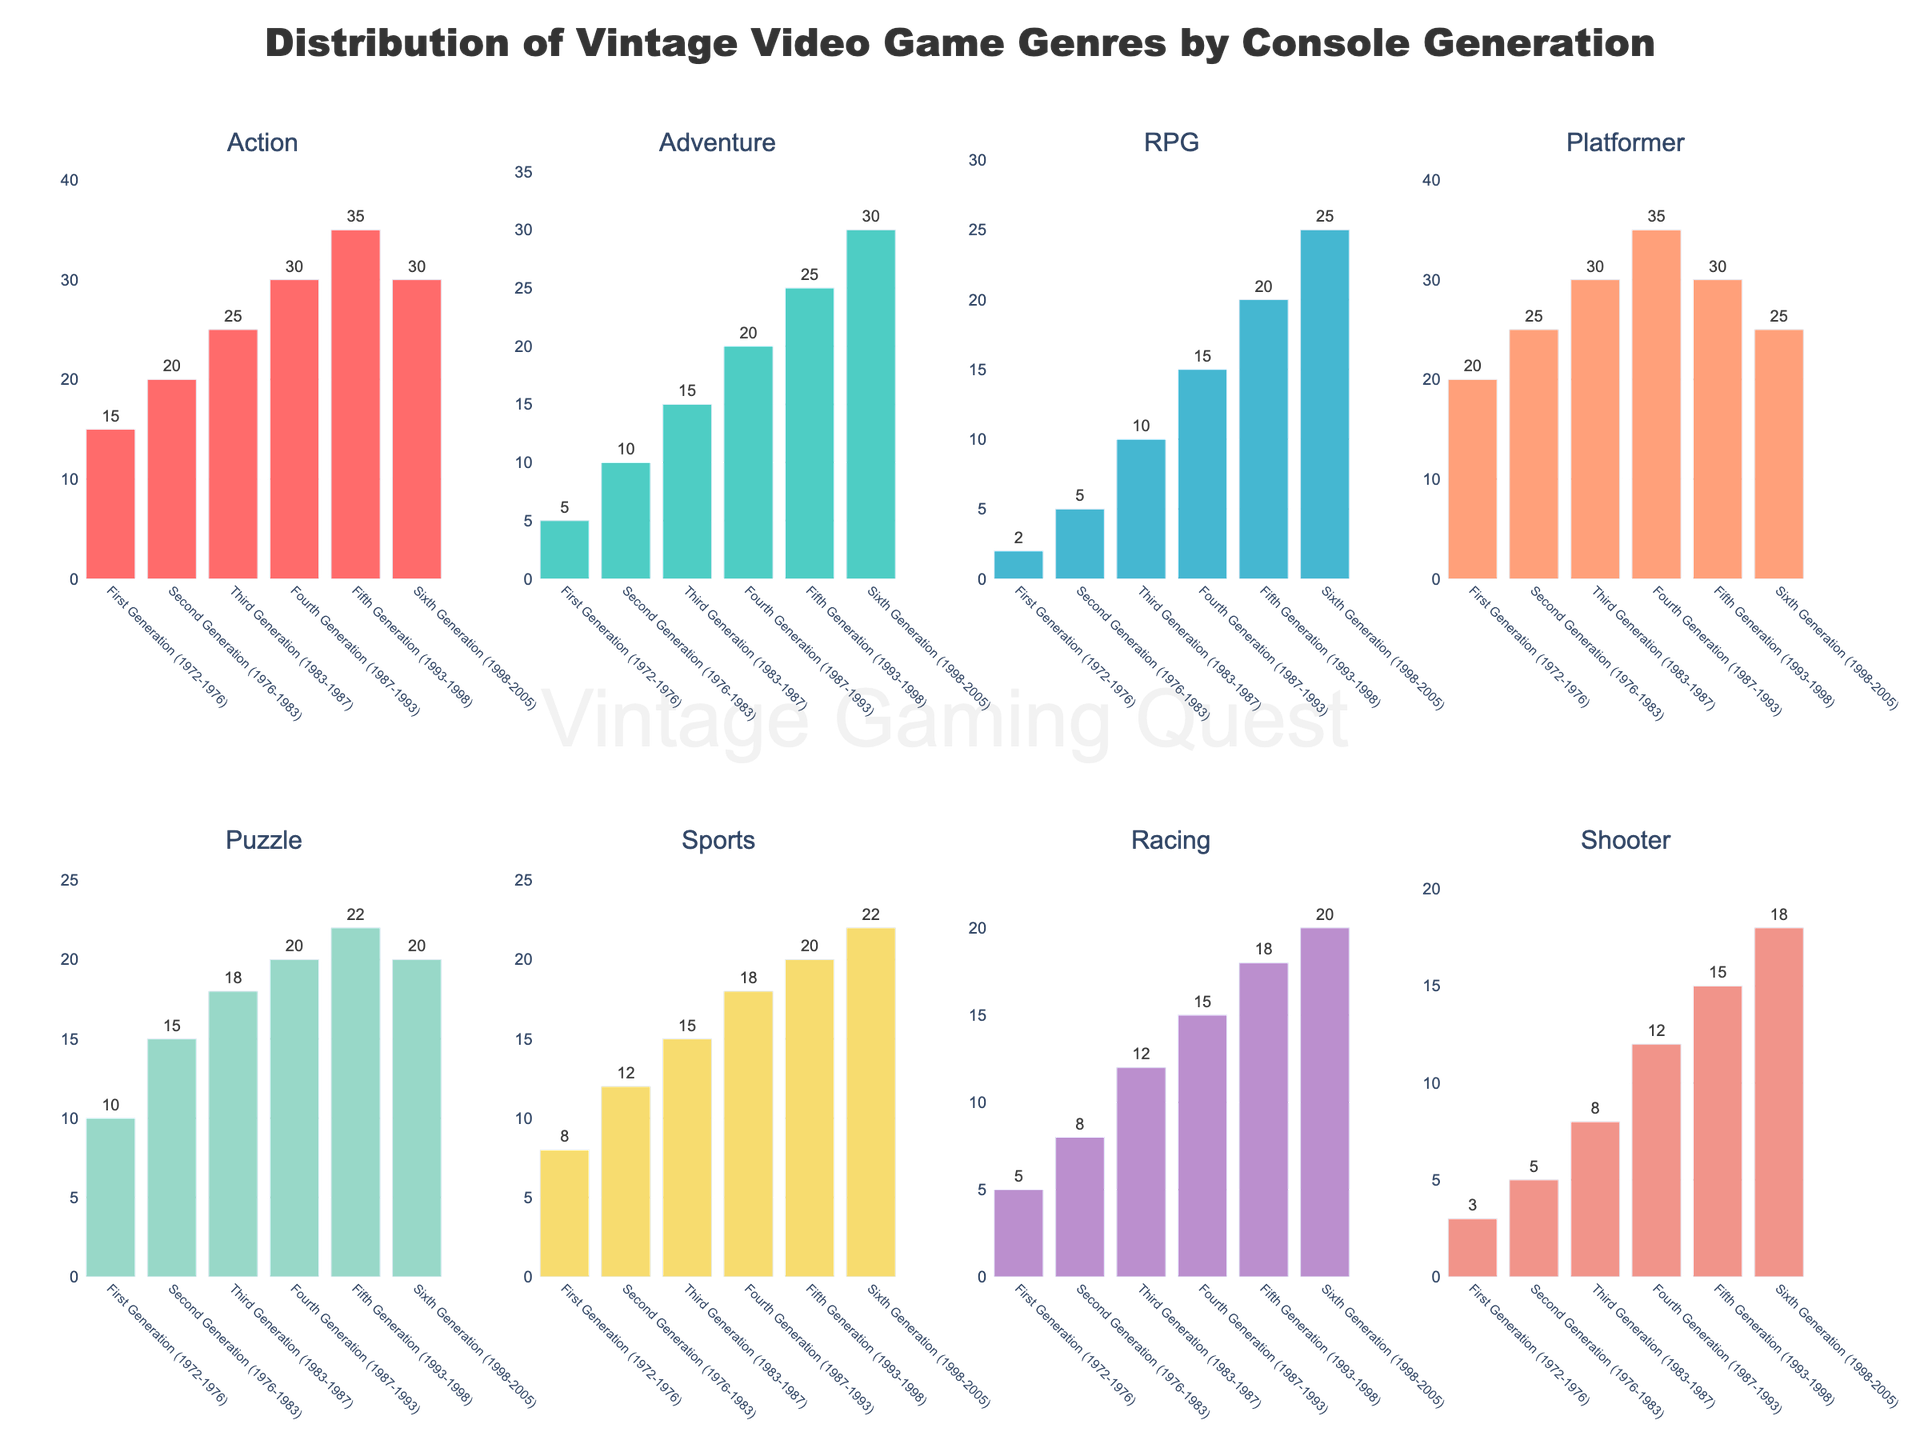Which console generation has the highest number of RPG games? By visually inspecting the height of the bars for the RPG genre across all console generations, the Fifth Generation has the highest bar for RPG games.
Answer: Fifth Generation (1993-1998) Which genre had the most significant increase in the number of games from the First to the Fourth Generation? Calculate the differences in the number of games between the Fourth and First Generations for each genre: Action (+15), Adventure (+15), RPG (+13), Platformer (+15), Puzzle (+10), Sports (+10), Racing (+10), Shooter (+9). The Adventure, Action, and Platformer genres had the most significant increase of 15 games each.
Answer: Adventure, Action, Platformer What's the average number of Sports games per console generation? Sum the number of Sports games across all console generations (8 + 12 + 15 + 18 + 20 + 22 = 95) and divide by the number of generations (6): 95 / 6.
Answer: 15.83 Which console generation saw the most significant decline in Platformer games compared to its preceding generation? Calculate the differences in the number of Platformer games between consecutive generations: First to Second (+5), Second to Third (+5), Third to Fourth (+5), Fourth to Fifth (-5), Fifth to Sixth (-5). The Fifth to Sixth Generations saw the most significant decline of 5 games.
Answer: Sixth Generation (1998-2005) Are there more Racing games or Shooter games in the Third Generation? Compare the heights of the bars for Racing and Shooter games in the Third Generation. Racing games have a higher bar (12) than Shooter games (8).
Answer: Racing games What is the total number of Puzzle games in the Second and Third Generations combined? Sum the number of Puzzle games in the Second (15) and Third (18) Generations: 15 + 18.
Answer: 33 Which genre consistently increased in numbers across all console generations? By inspecting the bars for each genre across all generations, RPG games consistently increased in number without any decline across generations.
Answer: RPG When did Adventure games catch up with or surpass Sports games in numbers? Inspect the bar height for Adventure and Sports genres across generations. In the Sixth Generation, Adventure (30) surpasses Sports (22).
Answer: Sixth Generation (1998-2005) How many more Platformer games were there in the Fourth Generation compared to the Second Generation? Subtract the number of Platformer games in the Second Generation (25) from the Fourth Generation (35): 35 - 25.
Answer: 10 Which genre had the least change in the number of games from the Fifth to Sixth Generation? Calculate the differences in the number of games between the Fifth and Sixth Generations for each genre: Action (-5), Adventure (+5), RPG (+5), Platformer (-5), Puzzle (-2), Sports (+2), Racing (+2), Shooter (+3). The Action and Platformer genres had the least change, both with a decline of 5 games.
Answer: Action, Platformer 